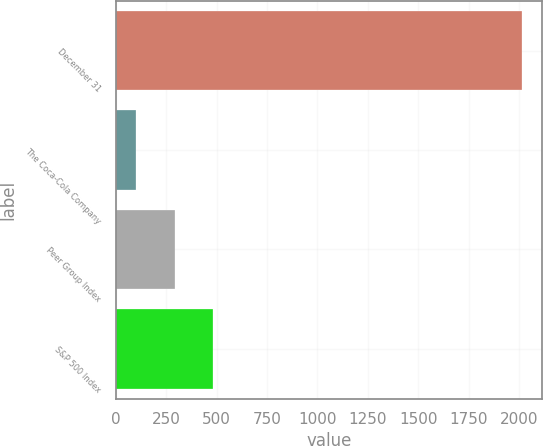Convert chart. <chart><loc_0><loc_0><loc_500><loc_500><bar_chart><fcel>December 31<fcel>The Coca-Cola Company<fcel>Peer Group Index<fcel>S&P 500 Index<nl><fcel>2012<fcel>100<fcel>291.2<fcel>482.4<nl></chart> 